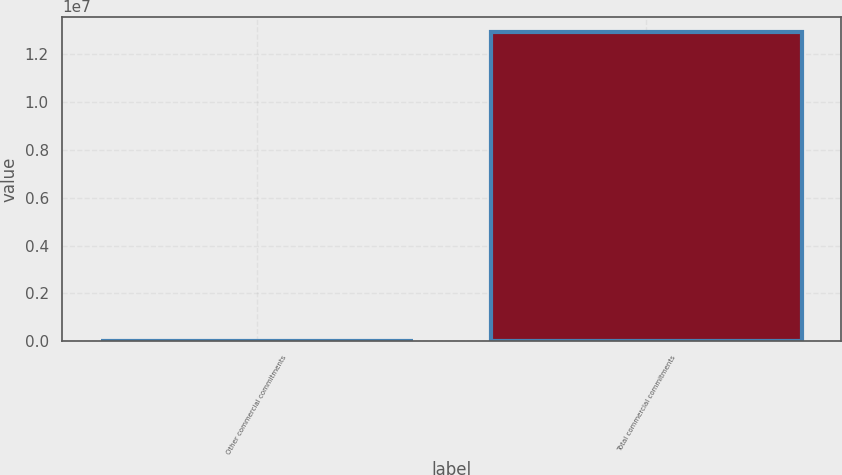Convert chart to OTSL. <chart><loc_0><loc_0><loc_500><loc_500><bar_chart><fcel>Other commercial commitments<fcel>Total commercial commitments<nl><fcel>5221<fcel>1.29286e+07<nl></chart> 